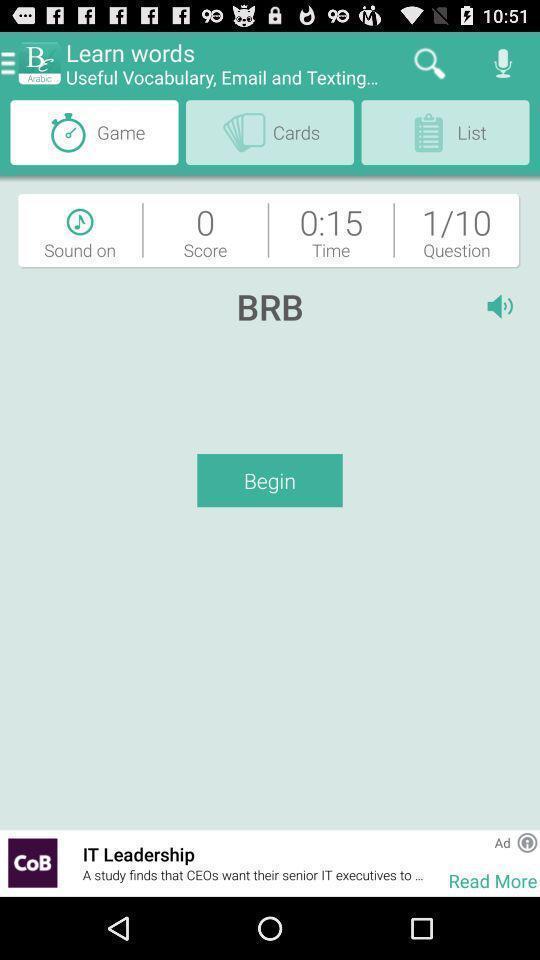Summarize the information in this screenshot. Page displaying with vocabulary testing. 